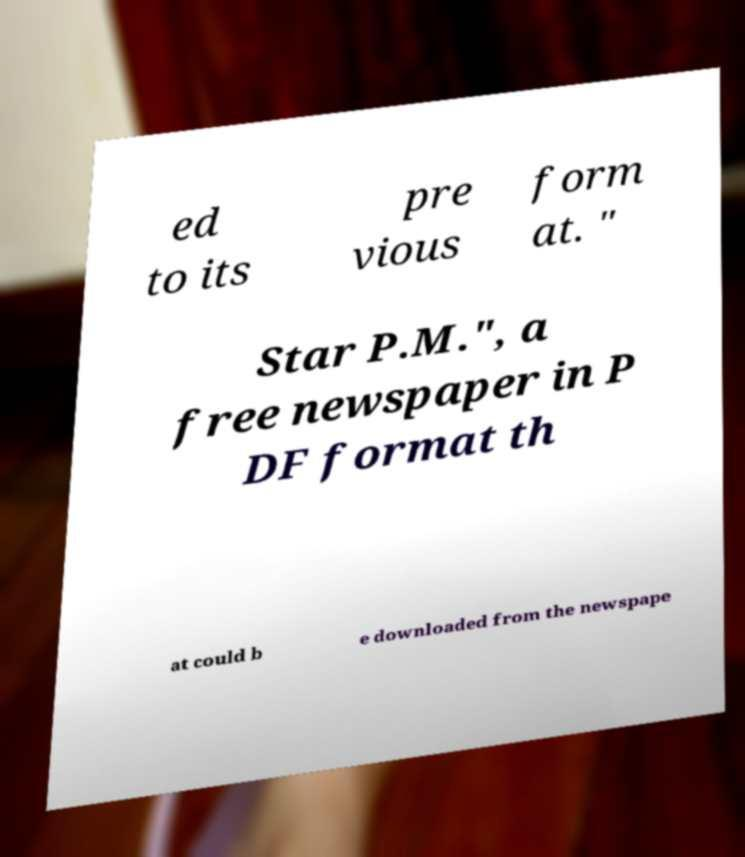For documentation purposes, I need the text within this image transcribed. Could you provide that? ed to its pre vious form at. " Star P.M.", a free newspaper in P DF format th at could b e downloaded from the newspape 